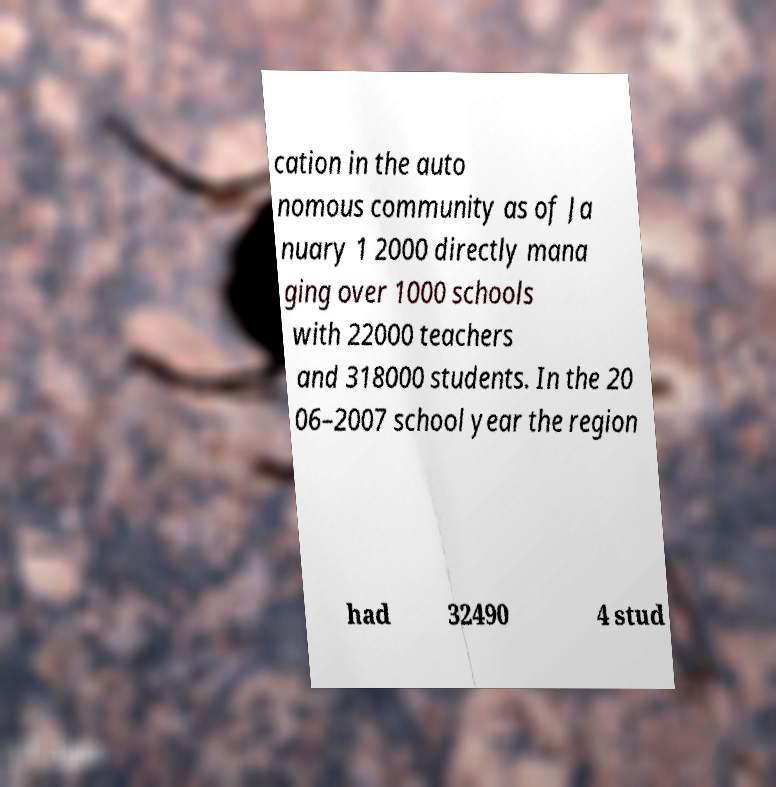For documentation purposes, I need the text within this image transcribed. Could you provide that? cation in the auto nomous community as of Ja nuary 1 2000 directly mana ging over 1000 schools with 22000 teachers and 318000 students. In the 20 06–2007 school year the region had 32490 4 stud 